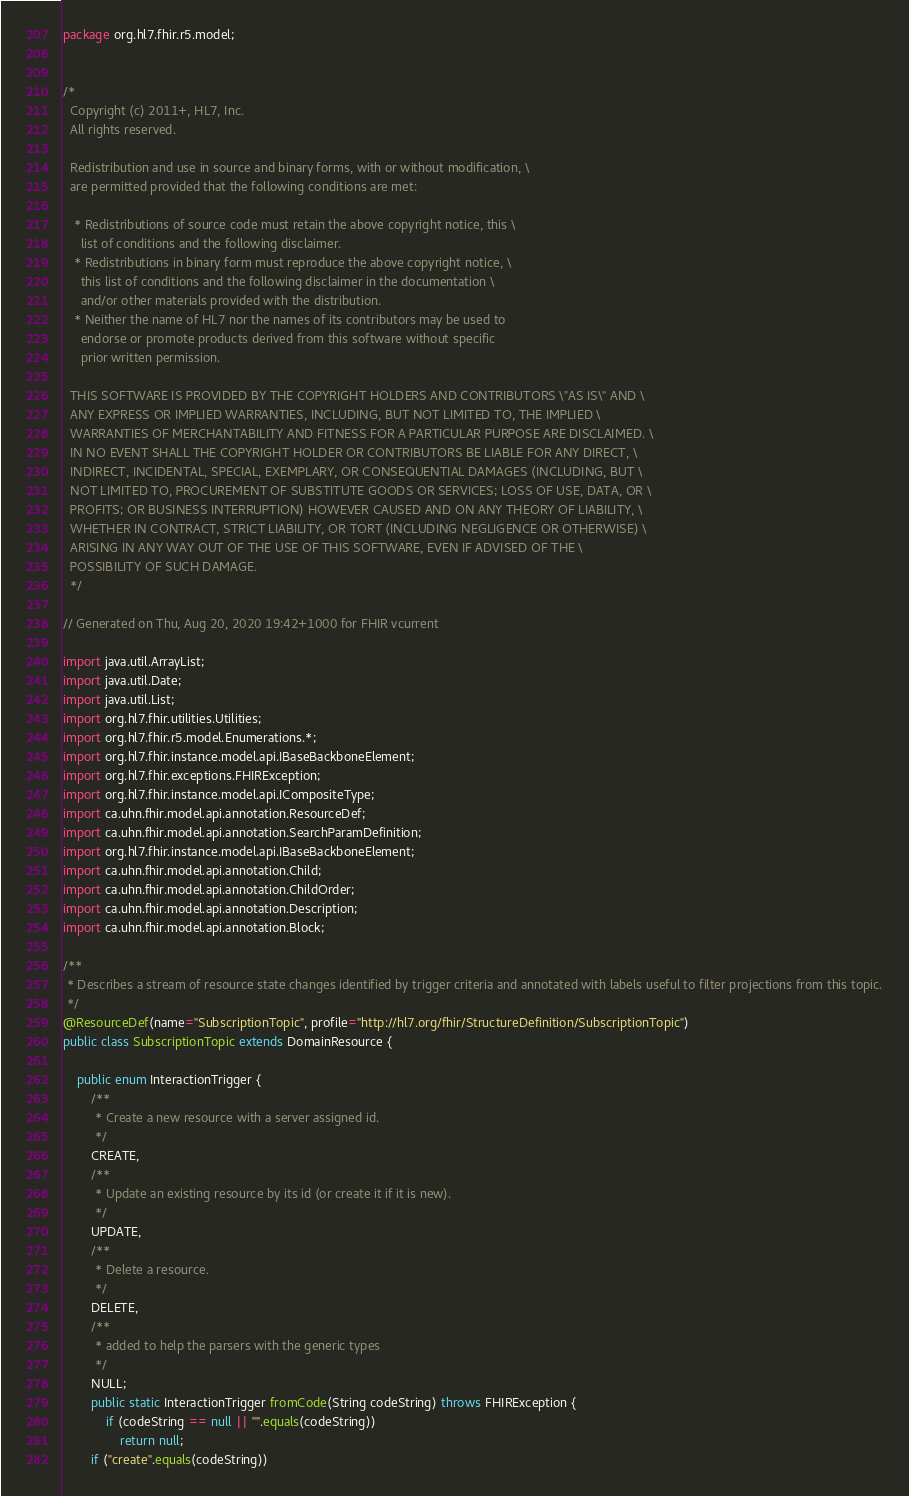<code> <loc_0><loc_0><loc_500><loc_500><_Java_>package org.hl7.fhir.r5.model;


/*
  Copyright (c) 2011+, HL7, Inc.
  All rights reserved.
  
  Redistribution and use in source and binary forms, with or without modification, \
  are permitted provided that the following conditions are met:
  
   * Redistributions of source code must retain the above copyright notice, this \
     list of conditions and the following disclaimer.
   * Redistributions in binary form must reproduce the above copyright notice, \
     this list of conditions and the following disclaimer in the documentation \
     and/or other materials provided with the distribution.
   * Neither the name of HL7 nor the names of its contributors may be used to 
     endorse or promote products derived from this software without specific 
     prior written permission.
  
  THIS SOFTWARE IS PROVIDED BY THE COPYRIGHT HOLDERS AND CONTRIBUTORS \"AS IS\" AND \
  ANY EXPRESS OR IMPLIED WARRANTIES, INCLUDING, BUT NOT LIMITED TO, THE IMPLIED \
  WARRANTIES OF MERCHANTABILITY AND FITNESS FOR A PARTICULAR PURPOSE ARE DISCLAIMED. \
  IN NO EVENT SHALL THE COPYRIGHT HOLDER OR CONTRIBUTORS BE LIABLE FOR ANY DIRECT, \
  INDIRECT, INCIDENTAL, SPECIAL, EXEMPLARY, OR CONSEQUENTIAL DAMAGES (INCLUDING, BUT \
  NOT LIMITED TO, PROCUREMENT OF SUBSTITUTE GOODS OR SERVICES; LOSS OF USE, DATA, OR \
  PROFITS; OR BUSINESS INTERRUPTION) HOWEVER CAUSED AND ON ANY THEORY OF LIABILITY, \
  WHETHER IN CONTRACT, STRICT LIABILITY, OR TORT (INCLUDING NEGLIGENCE OR OTHERWISE) \
  ARISING IN ANY WAY OUT OF THE USE OF THIS SOFTWARE, EVEN IF ADVISED OF THE \
  POSSIBILITY OF SUCH DAMAGE.
  */

// Generated on Thu, Aug 20, 2020 19:42+1000 for FHIR vcurrent

import java.util.ArrayList;
import java.util.Date;
import java.util.List;
import org.hl7.fhir.utilities.Utilities;
import org.hl7.fhir.r5.model.Enumerations.*;
import org.hl7.fhir.instance.model.api.IBaseBackboneElement;
import org.hl7.fhir.exceptions.FHIRException;
import org.hl7.fhir.instance.model.api.ICompositeType;
import ca.uhn.fhir.model.api.annotation.ResourceDef;
import ca.uhn.fhir.model.api.annotation.SearchParamDefinition;
import org.hl7.fhir.instance.model.api.IBaseBackboneElement;
import ca.uhn.fhir.model.api.annotation.Child;
import ca.uhn.fhir.model.api.annotation.ChildOrder;
import ca.uhn.fhir.model.api.annotation.Description;
import ca.uhn.fhir.model.api.annotation.Block;

/**
 * Describes a stream of resource state changes identified by trigger criteria and annotated with labels useful to filter projections from this topic.
 */
@ResourceDef(name="SubscriptionTopic", profile="http://hl7.org/fhir/StructureDefinition/SubscriptionTopic")
public class SubscriptionTopic extends DomainResource {

    public enum InteractionTrigger {
        /**
         * Create a new resource with a server assigned id.
         */
        CREATE, 
        /**
         * Update an existing resource by its id (or create it if it is new).
         */
        UPDATE, 
        /**
         * Delete a resource.
         */
        DELETE, 
        /**
         * added to help the parsers with the generic types
         */
        NULL;
        public static InteractionTrigger fromCode(String codeString) throws FHIRException {
            if (codeString == null || "".equals(codeString))
                return null;
        if ("create".equals(codeString))</code> 